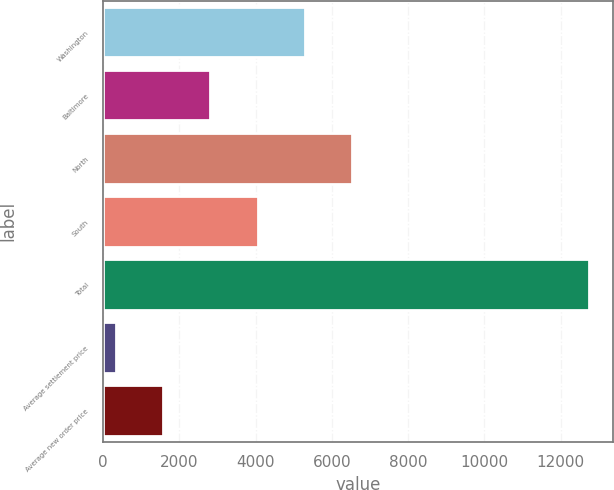Convert chart. <chart><loc_0><loc_0><loc_500><loc_500><bar_chart><fcel>Washington<fcel>Baltimore<fcel>North<fcel>South<fcel>Total<fcel>Average settlement price<fcel>Average new order price<nl><fcel>5298.92<fcel>2815.56<fcel>6540.6<fcel>4057.24<fcel>12749<fcel>332.2<fcel>1573.88<nl></chart> 